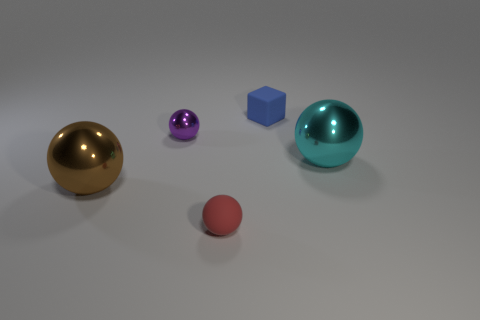Add 4 tiny cyan shiny things. How many objects exist? 9 Subtract all gray spheres. Subtract all brown cylinders. How many spheres are left? 4 Subtract all cubes. How many objects are left? 4 Subtract all red rubber spheres. Subtract all large cyan metallic objects. How many objects are left? 3 Add 5 small objects. How many small objects are left? 8 Add 3 tiny matte blocks. How many tiny matte blocks exist? 4 Subtract 0 gray cubes. How many objects are left? 5 